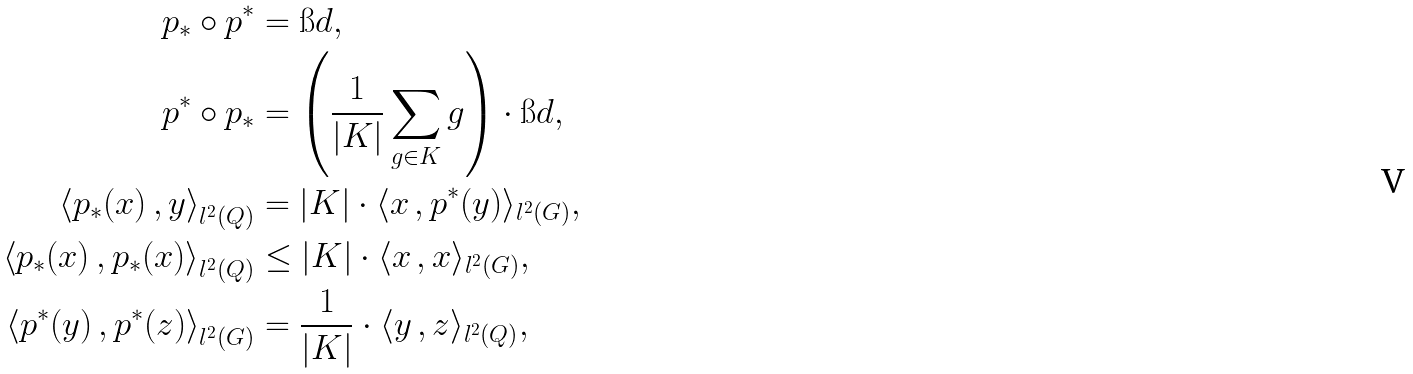<formula> <loc_0><loc_0><loc_500><loc_500>p _ { * } \circ p ^ { * } & = \i d , \\ p ^ { * } \circ p _ { * } & = \left ( \frac { 1 } { | K | } \sum _ { g \in K } g \right ) \cdot \i d , \\ \left \langle p _ { * } ( x ) \, , y \right \rangle _ { l ^ { 2 } ( Q ) } & = | K | \cdot \langle x \, , p ^ { * } ( y ) \rangle _ { l ^ { 2 } ( G ) } , \\ \left \langle p _ { * } ( x ) \, , p _ { * } ( x ) \right \rangle _ { l ^ { 2 } ( Q ) } & \leq | K | \cdot \langle x \, , x \rangle _ { l ^ { 2 } ( G ) } , \\ \left \langle p ^ { * } ( y ) \, , p ^ { * } ( z ) \right \rangle _ { l ^ { 2 } ( G ) } & = \frac { 1 } { | K | } \cdot \langle y \, , z \rangle _ { l ^ { 2 } ( Q ) } ,</formula> 